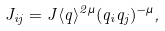<formula> <loc_0><loc_0><loc_500><loc_500>J _ { i j } = J \langle q \rangle ^ { 2 \mu } ( q _ { i } q _ { j } ) ^ { - \mu } ,</formula> 